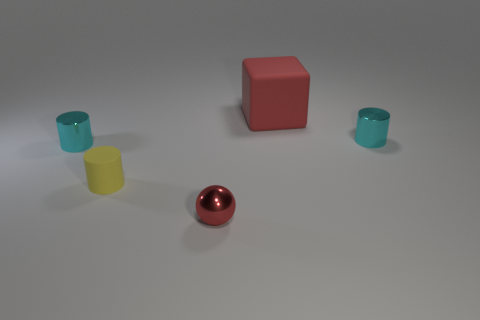What number of objects are cylinders that are left of the tiny rubber thing or big matte objects?
Provide a succinct answer. 2. Are there any red shiny things that have the same size as the yellow cylinder?
Keep it short and to the point. Yes. There is a cyan thing that is to the right of the yellow cylinder; is there a small object to the left of it?
Give a very brief answer. Yes. What number of balls are big rubber objects or small yellow rubber objects?
Your response must be concise. 0. Is there a cyan thing of the same shape as the tiny yellow matte thing?
Make the answer very short. Yes. What is the shape of the tiny red object?
Offer a very short reply. Sphere. How many objects are either tiny red metal objects or small gray matte balls?
Your response must be concise. 1. Is the size of the matte object left of the tiny red thing the same as the cyan cylinder that is on the left side of the tiny red sphere?
Provide a short and direct response. Yes. What number of other things are made of the same material as the small red object?
Make the answer very short. 2. Is the number of cyan things to the left of the yellow cylinder greater than the number of tiny yellow rubber things behind the tiny red shiny ball?
Offer a very short reply. No. 